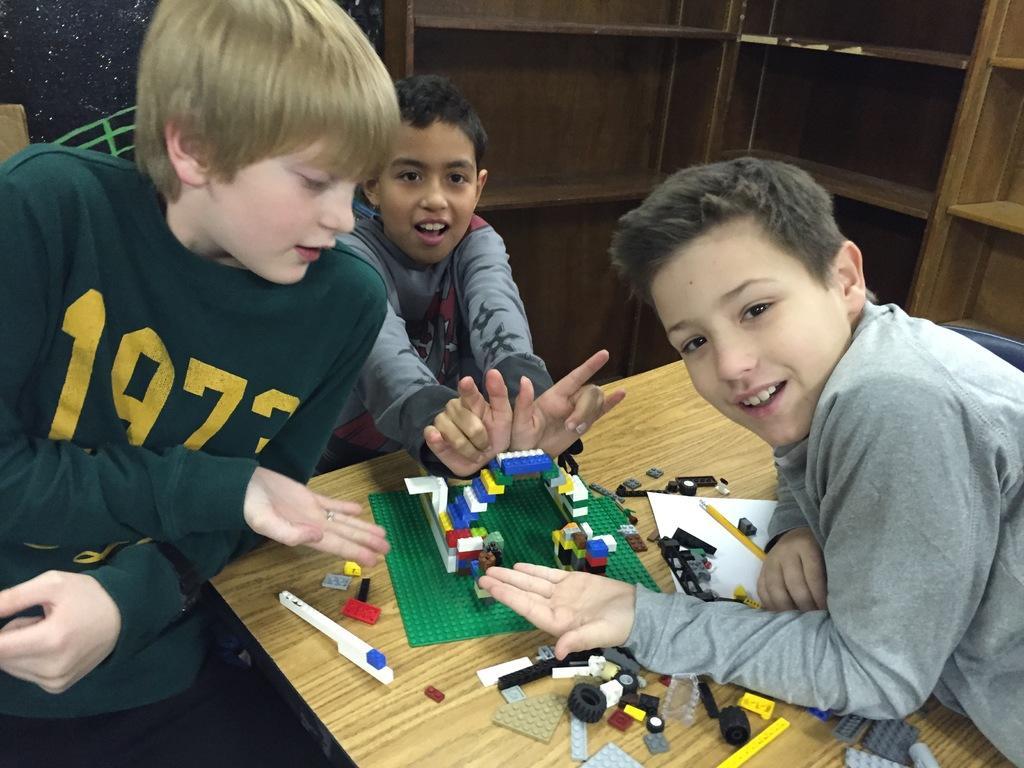Can you describe this image briefly? In this image I can see three people with different color dresses. In-front of these people I can see the table. On the table there is a lego which is colorful. In the back I can see the rack. 